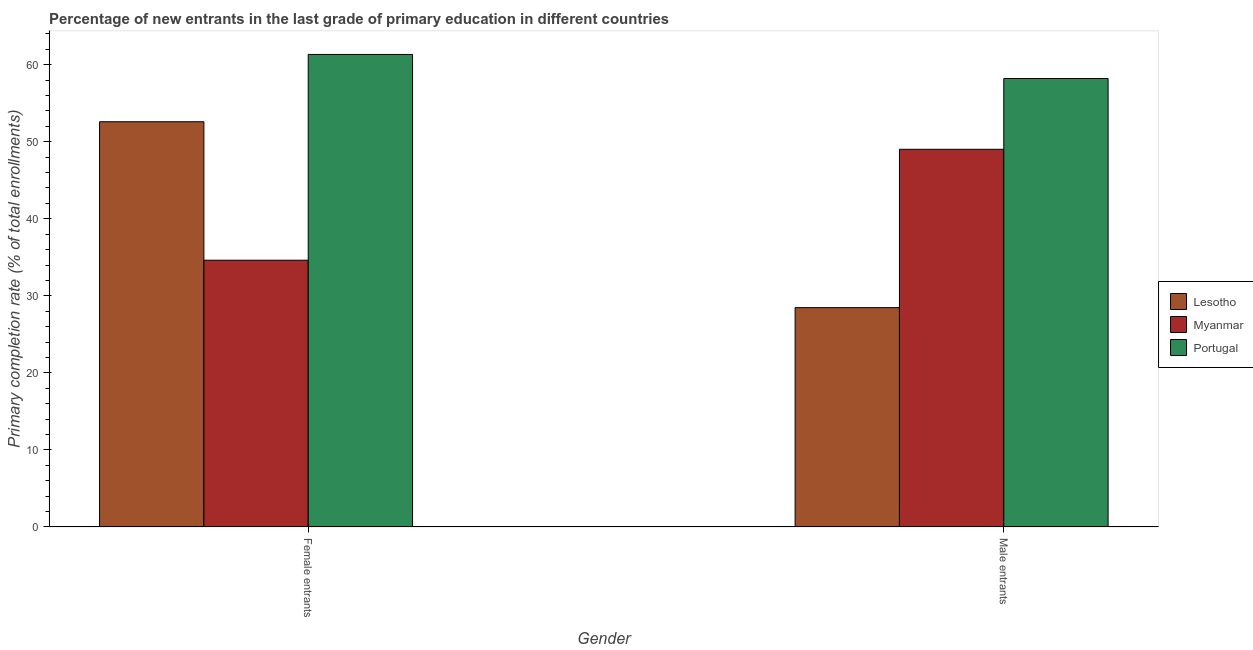How many groups of bars are there?
Offer a terse response. 2. Are the number of bars on each tick of the X-axis equal?
Your response must be concise. Yes. What is the label of the 1st group of bars from the left?
Your answer should be compact. Female entrants. What is the primary completion rate of female entrants in Lesotho?
Ensure brevity in your answer.  52.59. Across all countries, what is the maximum primary completion rate of female entrants?
Offer a terse response. 61.32. Across all countries, what is the minimum primary completion rate of female entrants?
Provide a succinct answer. 34.62. In which country was the primary completion rate of male entrants maximum?
Offer a terse response. Portugal. In which country was the primary completion rate of female entrants minimum?
Give a very brief answer. Myanmar. What is the total primary completion rate of male entrants in the graph?
Make the answer very short. 135.68. What is the difference between the primary completion rate of male entrants in Portugal and that in Myanmar?
Your response must be concise. 9.18. What is the difference between the primary completion rate of male entrants in Lesotho and the primary completion rate of female entrants in Myanmar?
Ensure brevity in your answer.  -6.15. What is the average primary completion rate of female entrants per country?
Your answer should be very brief. 49.51. What is the difference between the primary completion rate of female entrants and primary completion rate of male entrants in Myanmar?
Make the answer very short. -14.39. In how many countries, is the primary completion rate of male entrants greater than 44 %?
Keep it short and to the point. 2. What is the ratio of the primary completion rate of male entrants in Myanmar to that in Lesotho?
Ensure brevity in your answer.  1.72. Is the primary completion rate of female entrants in Portugal less than that in Myanmar?
Give a very brief answer. No. In how many countries, is the primary completion rate of female entrants greater than the average primary completion rate of female entrants taken over all countries?
Give a very brief answer. 2. What does the 1st bar from the left in Male entrants represents?
Provide a succinct answer. Lesotho. How many bars are there?
Offer a terse response. 6. Are all the bars in the graph horizontal?
Your response must be concise. No. What is the difference between two consecutive major ticks on the Y-axis?
Provide a succinct answer. 10. Are the values on the major ticks of Y-axis written in scientific E-notation?
Offer a terse response. No. Where does the legend appear in the graph?
Offer a terse response. Center right. How many legend labels are there?
Ensure brevity in your answer.  3. What is the title of the graph?
Your answer should be compact. Percentage of new entrants in the last grade of primary education in different countries. What is the label or title of the X-axis?
Your answer should be very brief. Gender. What is the label or title of the Y-axis?
Keep it short and to the point. Primary completion rate (% of total enrollments). What is the Primary completion rate (% of total enrollments) in Lesotho in Female entrants?
Give a very brief answer. 52.59. What is the Primary completion rate (% of total enrollments) in Myanmar in Female entrants?
Offer a very short reply. 34.62. What is the Primary completion rate (% of total enrollments) of Portugal in Female entrants?
Give a very brief answer. 61.32. What is the Primary completion rate (% of total enrollments) of Lesotho in Male entrants?
Give a very brief answer. 28.47. What is the Primary completion rate (% of total enrollments) in Myanmar in Male entrants?
Ensure brevity in your answer.  49.02. What is the Primary completion rate (% of total enrollments) of Portugal in Male entrants?
Keep it short and to the point. 58.2. Across all Gender, what is the maximum Primary completion rate (% of total enrollments) in Lesotho?
Offer a very short reply. 52.59. Across all Gender, what is the maximum Primary completion rate (% of total enrollments) in Myanmar?
Provide a short and direct response. 49.02. Across all Gender, what is the maximum Primary completion rate (% of total enrollments) of Portugal?
Make the answer very short. 61.32. Across all Gender, what is the minimum Primary completion rate (% of total enrollments) of Lesotho?
Keep it short and to the point. 28.47. Across all Gender, what is the minimum Primary completion rate (% of total enrollments) of Myanmar?
Provide a succinct answer. 34.62. Across all Gender, what is the minimum Primary completion rate (% of total enrollments) in Portugal?
Provide a succinct answer. 58.2. What is the total Primary completion rate (% of total enrollments) of Lesotho in the graph?
Make the answer very short. 81.06. What is the total Primary completion rate (% of total enrollments) in Myanmar in the graph?
Give a very brief answer. 83.64. What is the total Primary completion rate (% of total enrollments) of Portugal in the graph?
Your response must be concise. 119.52. What is the difference between the Primary completion rate (% of total enrollments) of Lesotho in Female entrants and that in Male entrants?
Offer a very short reply. 24.13. What is the difference between the Primary completion rate (% of total enrollments) in Myanmar in Female entrants and that in Male entrants?
Give a very brief answer. -14.39. What is the difference between the Primary completion rate (% of total enrollments) of Portugal in Female entrants and that in Male entrants?
Give a very brief answer. 3.12. What is the difference between the Primary completion rate (% of total enrollments) in Lesotho in Female entrants and the Primary completion rate (% of total enrollments) in Myanmar in Male entrants?
Keep it short and to the point. 3.58. What is the difference between the Primary completion rate (% of total enrollments) in Lesotho in Female entrants and the Primary completion rate (% of total enrollments) in Portugal in Male entrants?
Keep it short and to the point. -5.61. What is the difference between the Primary completion rate (% of total enrollments) in Myanmar in Female entrants and the Primary completion rate (% of total enrollments) in Portugal in Male entrants?
Ensure brevity in your answer.  -23.58. What is the average Primary completion rate (% of total enrollments) in Lesotho per Gender?
Keep it short and to the point. 40.53. What is the average Primary completion rate (% of total enrollments) in Myanmar per Gender?
Make the answer very short. 41.82. What is the average Primary completion rate (% of total enrollments) of Portugal per Gender?
Provide a succinct answer. 59.76. What is the difference between the Primary completion rate (% of total enrollments) of Lesotho and Primary completion rate (% of total enrollments) of Myanmar in Female entrants?
Make the answer very short. 17.97. What is the difference between the Primary completion rate (% of total enrollments) of Lesotho and Primary completion rate (% of total enrollments) of Portugal in Female entrants?
Your response must be concise. -8.73. What is the difference between the Primary completion rate (% of total enrollments) of Myanmar and Primary completion rate (% of total enrollments) of Portugal in Female entrants?
Make the answer very short. -26.7. What is the difference between the Primary completion rate (% of total enrollments) of Lesotho and Primary completion rate (% of total enrollments) of Myanmar in Male entrants?
Give a very brief answer. -20.55. What is the difference between the Primary completion rate (% of total enrollments) in Lesotho and Primary completion rate (% of total enrollments) in Portugal in Male entrants?
Make the answer very short. -29.73. What is the difference between the Primary completion rate (% of total enrollments) in Myanmar and Primary completion rate (% of total enrollments) in Portugal in Male entrants?
Provide a short and direct response. -9.18. What is the ratio of the Primary completion rate (% of total enrollments) of Lesotho in Female entrants to that in Male entrants?
Ensure brevity in your answer.  1.85. What is the ratio of the Primary completion rate (% of total enrollments) in Myanmar in Female entrants to that in Male entrants?
Offer a very short reply. 0.71. What is the ratio of the Primary completion rate (% of total enrollments) in Portugal in Female entrants to that in Male entrants?
Your response must be concise. 1.05. What is the difference between the highest and the second highest Primary completion rate (% of total enrollments) of Lesotho?
Offer a terse response. 24.13. What is the difference between the highest and the second highest Primary completion rate (% of total enrollments) of Myanmar?
Make the answer very short. 14.39. What is the difference between the highest and the second highest Primary completion rate (% of total enrollments) of Portugal?
Provide a succinct answer. 3.12. What is the difference between the highest and the lowest Primary completion rate (% of total enrollments) in Lesotho?
Your response must be concise. 24.13. What is the difference between the highest and the lowest Primary completion rate (% of total enrollments) of Myanmar?
Your answer should be compact. 14.39. What is the difference between the highest and the lowest Primary completion rate (% of total enrollments) in Portugal?
Give a very brief answer. 3.12. 